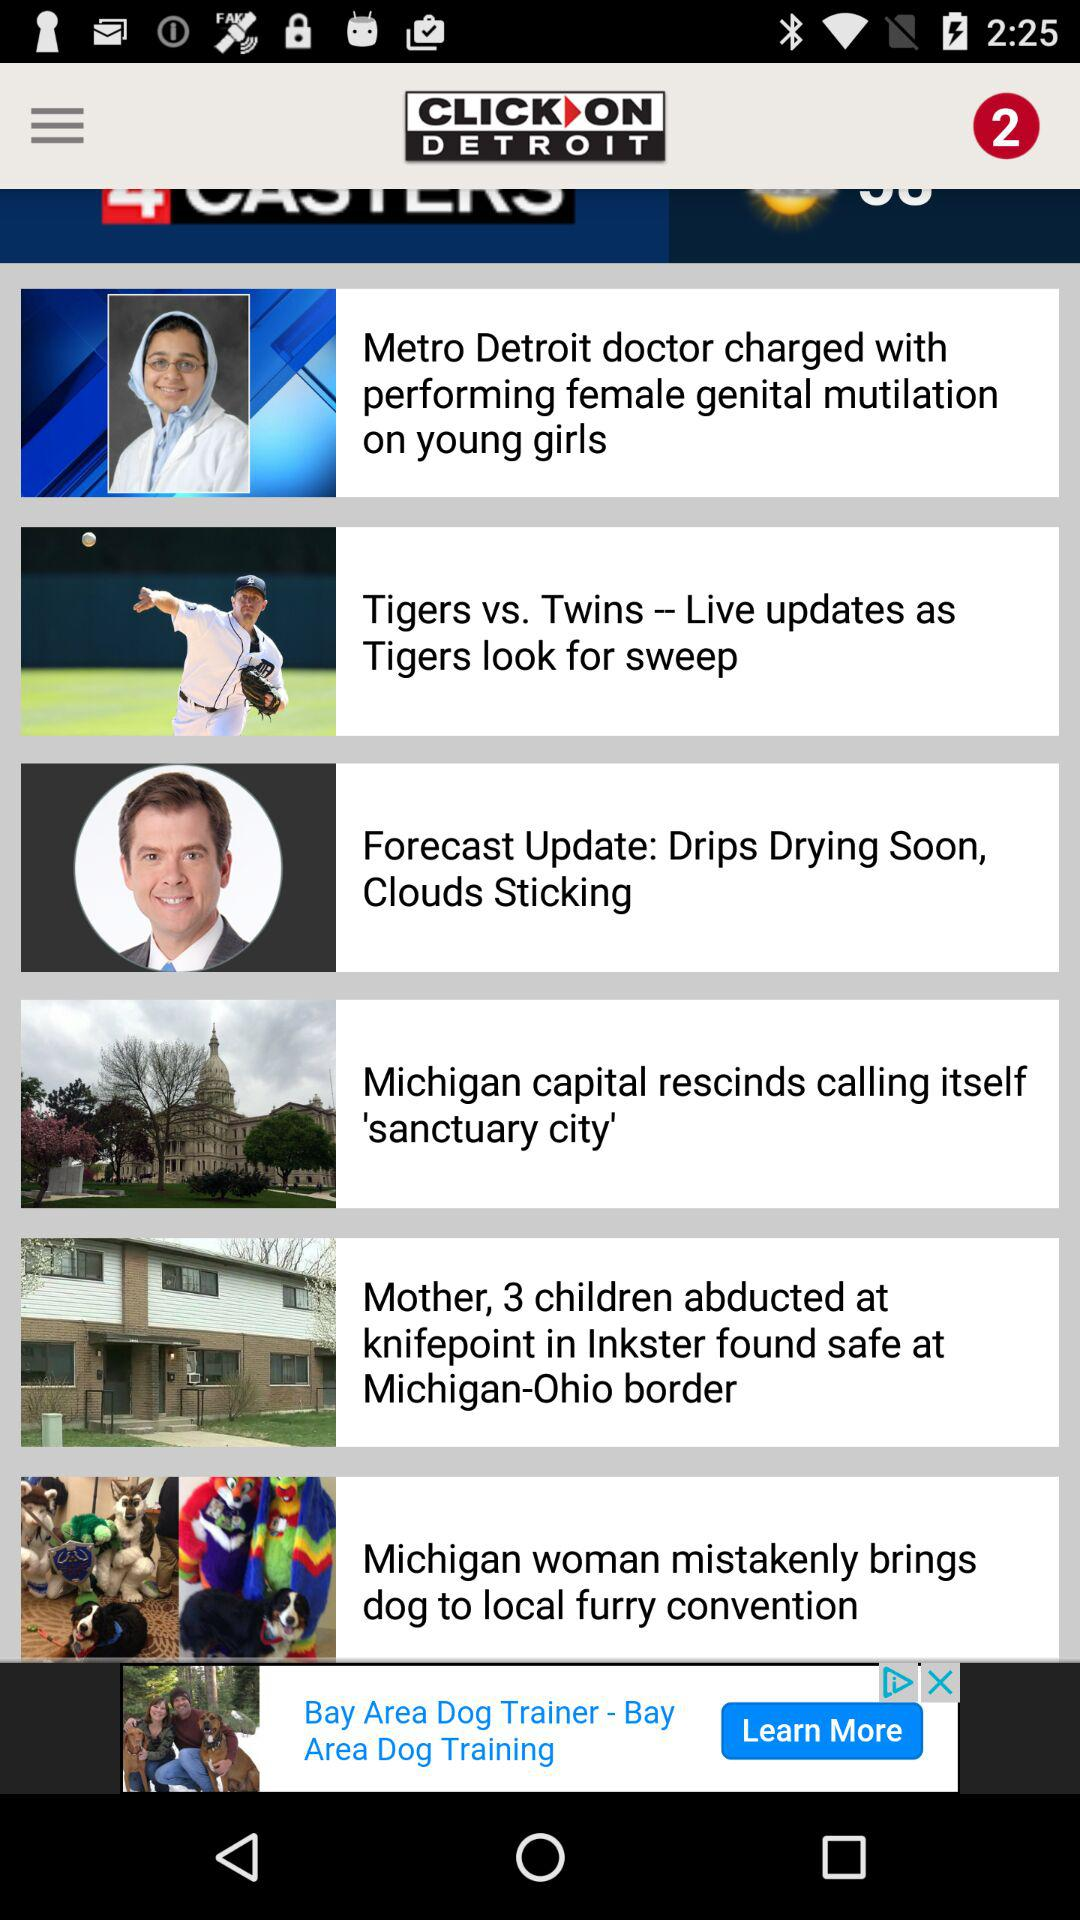What is the application name? The application name is "ClickOnDetroit WDIV Local 4". 